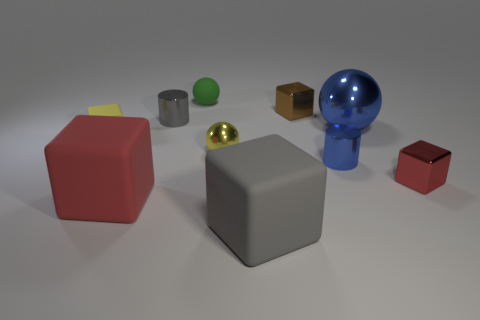Are there more yellow balls than tiny yellow objects?
Offer a very short reply. No. There is a small cylinder that is in front of the large object that is behind the metal cube that is right of the blue cylinder; what color is it?
Offer a terse response. Blue. Is the color of the rubber object on the right side of the small matte ball the same as the shiny thing that is right of the big blue metallic object?
Offer a very short reply. No. There is a ball that is right of the gray matte thing; what number of brown metal things are to the right of it?
Offer a very short reply. 0. Are any brown shiny blocks visible?
Offer a very short reply. Yes. What number of other things are the same color as the tiny matte ball?
Give a very brief answer. 0. Is the number of small metallic cylinders less than the number of tiny rubber balls?
Ensure brevity in your answer.  No. The gray thing behind the red thing right of the small blue thing is what shape?
Ensure brevity in your answer.  Cylinder. Are there any tiny green rubber objects right of the gray cube?
Give a very brief answer. No. The metal sphere that is the same size as the green object is what color?
Provide a short and direct response. Yellow. 